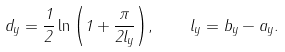Convert formula to latex. <formula><loc_0><loc_0><loc_500><loc_500>d _ { y } = \frac { 1 } { 2 } \ln { \left ( 1 + \frac { \pi } { 2 l _ { y } } \right ) } , \quad l _ { y } = b _ { y } - a _ { y } .</formula> 